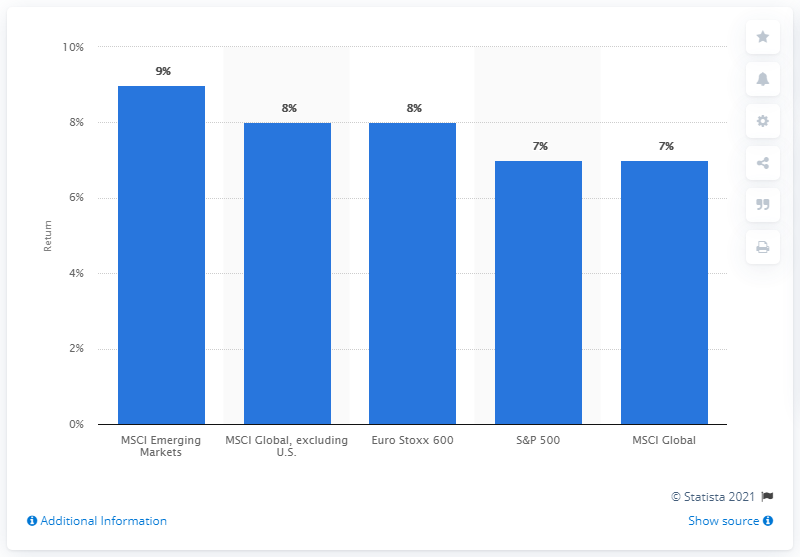Identify some key points in this picture. The average of all the bars is 7.8. The S&P 500 is expected to have a projected return of 7% based on the chart analysis. 